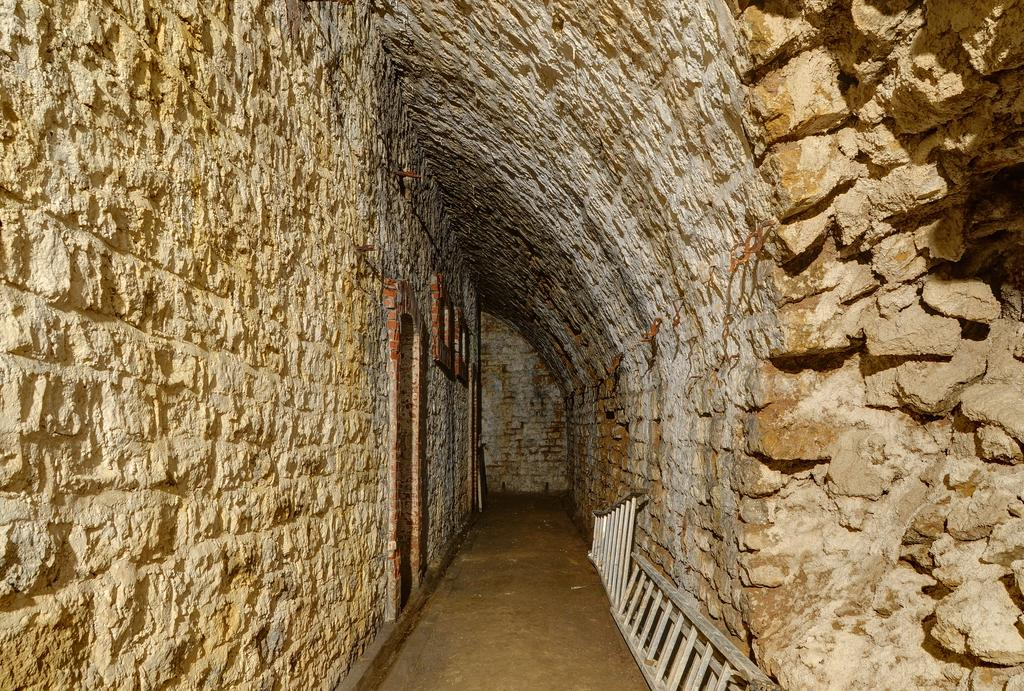What is the main structure in the image? There is a wall in the image. What is happening with the wall on the right side of the image? There is a collapsed wall on the right side of the image. What objects are near the collapsed wall? There are stones present near the collapsed wall. What else can be seen related to the wall in the image? There are two ladders leaning on the wall. What type of peace and quiet can be observed in the image? The image does not depict peace and quiet, as there are ladders and a collapsed wall, which suggest some activity or work is being done. 